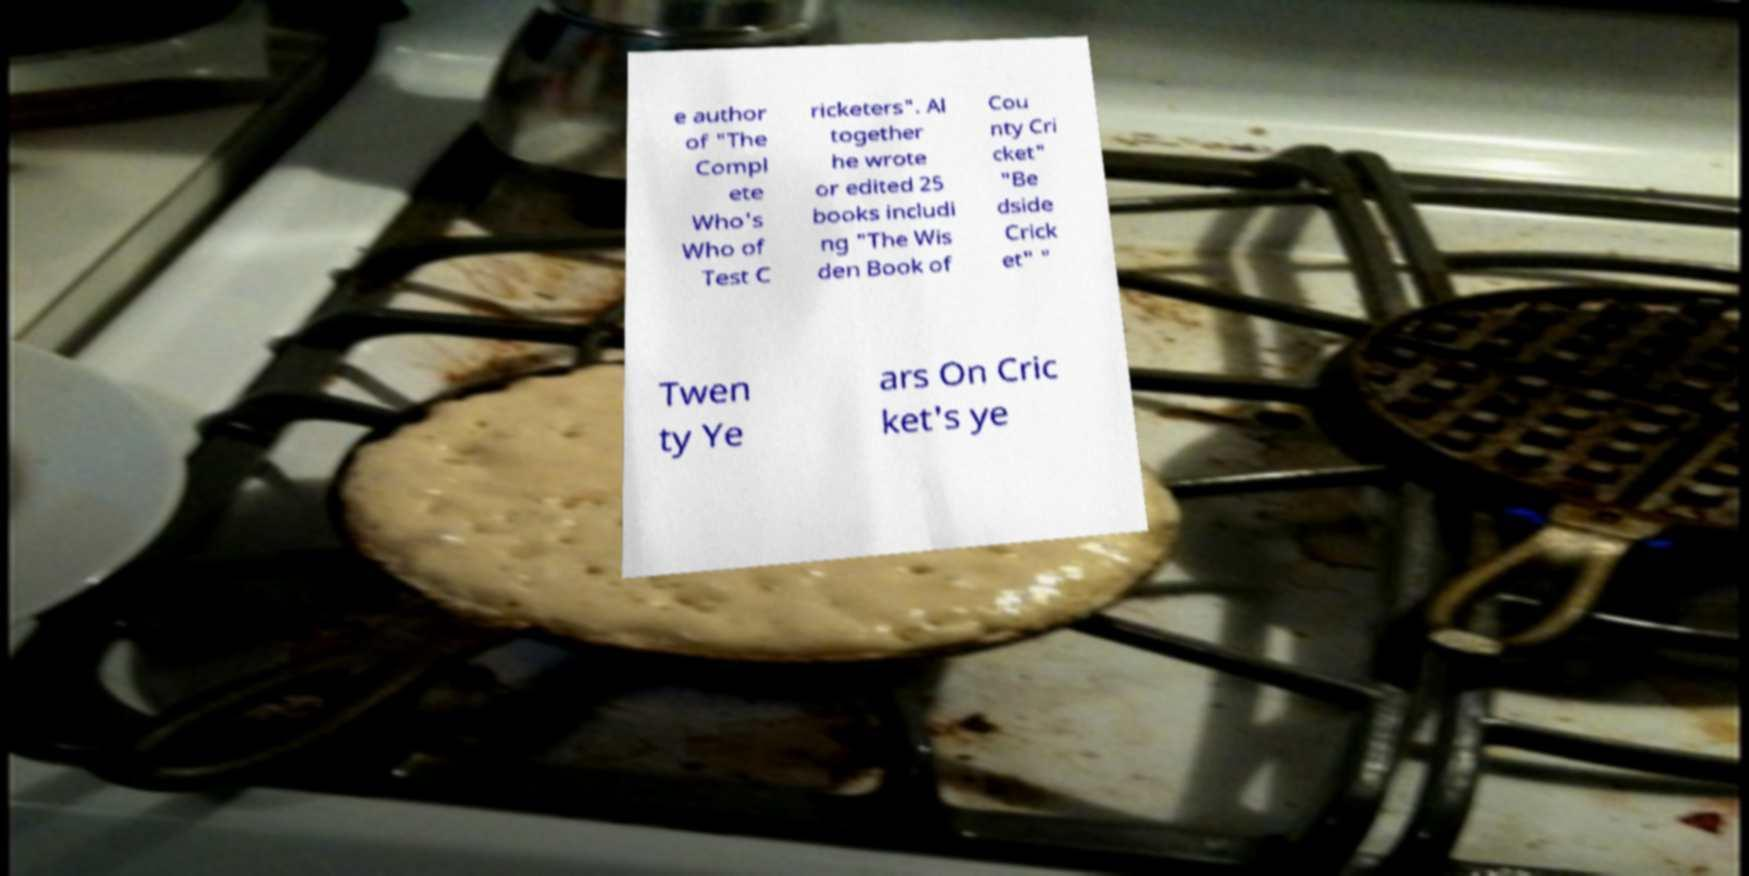Can you accurately transcribe the text from the provided image for me? e author of "The Compl ete Who's Who of Test C ricketers". Al together he wrote or edited 25 books includi ng "The Wis den Book of Cou nty Cri cket" "Be dside Crick et" " Twen ty Ye ars On Cric ket's ye 